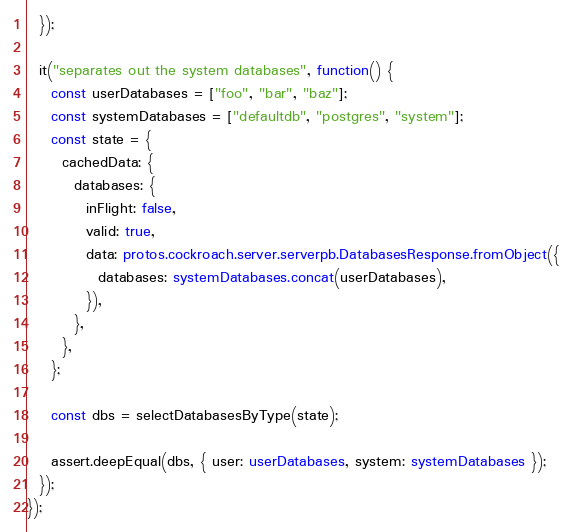Convert code to text. <code><loc_0><loc_0><loc_500><loc_500><_TypeScript_>  });

  it("separates out the system databases", function() {
    const userDatabases = ["foo", "bar", "baz"];
    const systemDatabases = ["defaultdb", "postgres", "system"];
    const state = {
      cachedData: {
        databases: {
          inFlight: false,
          valid: true,
          data: protos.cockroach.server.serverpb.DatabasesResponse.fromObject({
            databases: systemDatabases.concat(userDatabases),
          }),
        },
      },
    };

    const dbs = selectDatabasesByType(state);

    assert.deepEqual(dbs, { user: userDatabases, system: systemDatabases });
  });
});
</code> 